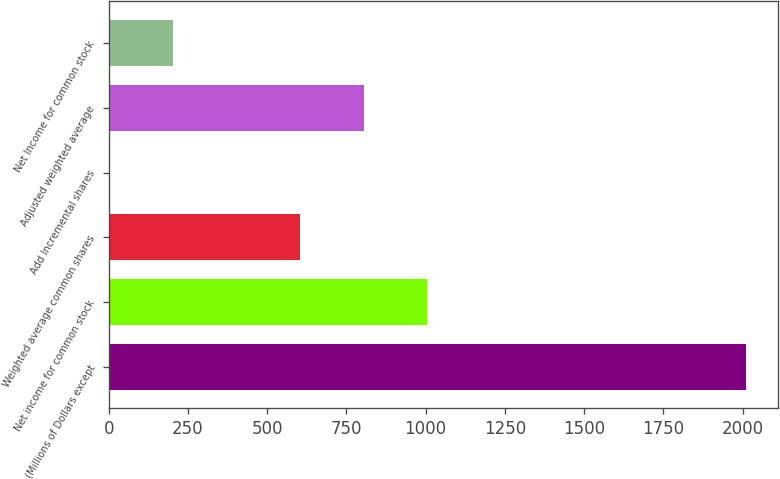<chart> <loc_0><loc_0><loc_500><loc_500><bar_chart><fcel>(Millions of Dollars except<fcel>Net income for common stock<fcel>Weighted average common shares<fcel>Add Incremental shares<fcel>Adjusted weighted average<fcel>Net Income for common stock<nl><fcel>2010<fcel>1005.8<fcel>604.12<fcel>1.6<fcel>804.96<fcel>202.44<nl></chart> 